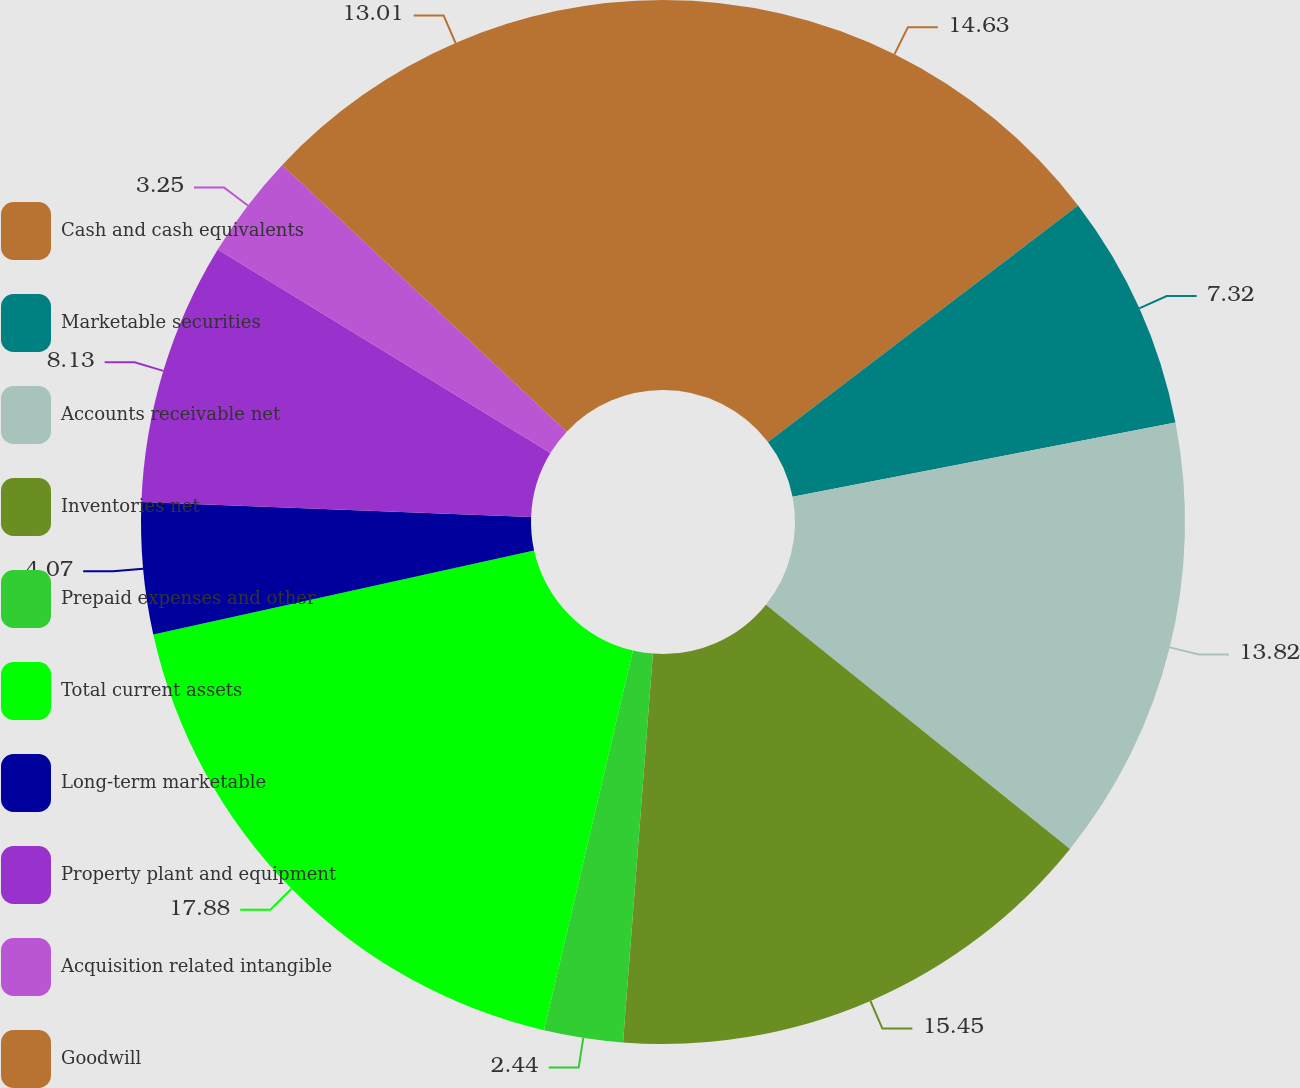<chart> <loc_0><loc_0><loc_500><loc_500><pie_chart><fcel>Cash and cash equivalents<fcel>Marketable securities<fcel>Accounts receivable net<fcel>Inventories net<fcel>Prepaid expenses and other<fcel>Total current assets<fcel>Long-term marketable<fcel>Property plant and equipment<fcel>Acquisition related intangible<fcel>Goodwill<nl><fcel>14.63%<fcel>7.32%<fcel>13.82%<fcel>15.45%<fcel>2.44%<fcel>17.88%<fcel>4.07%<fcel>8.13%<fcel>3.25%<fcel>13.01%<nl></chart> 